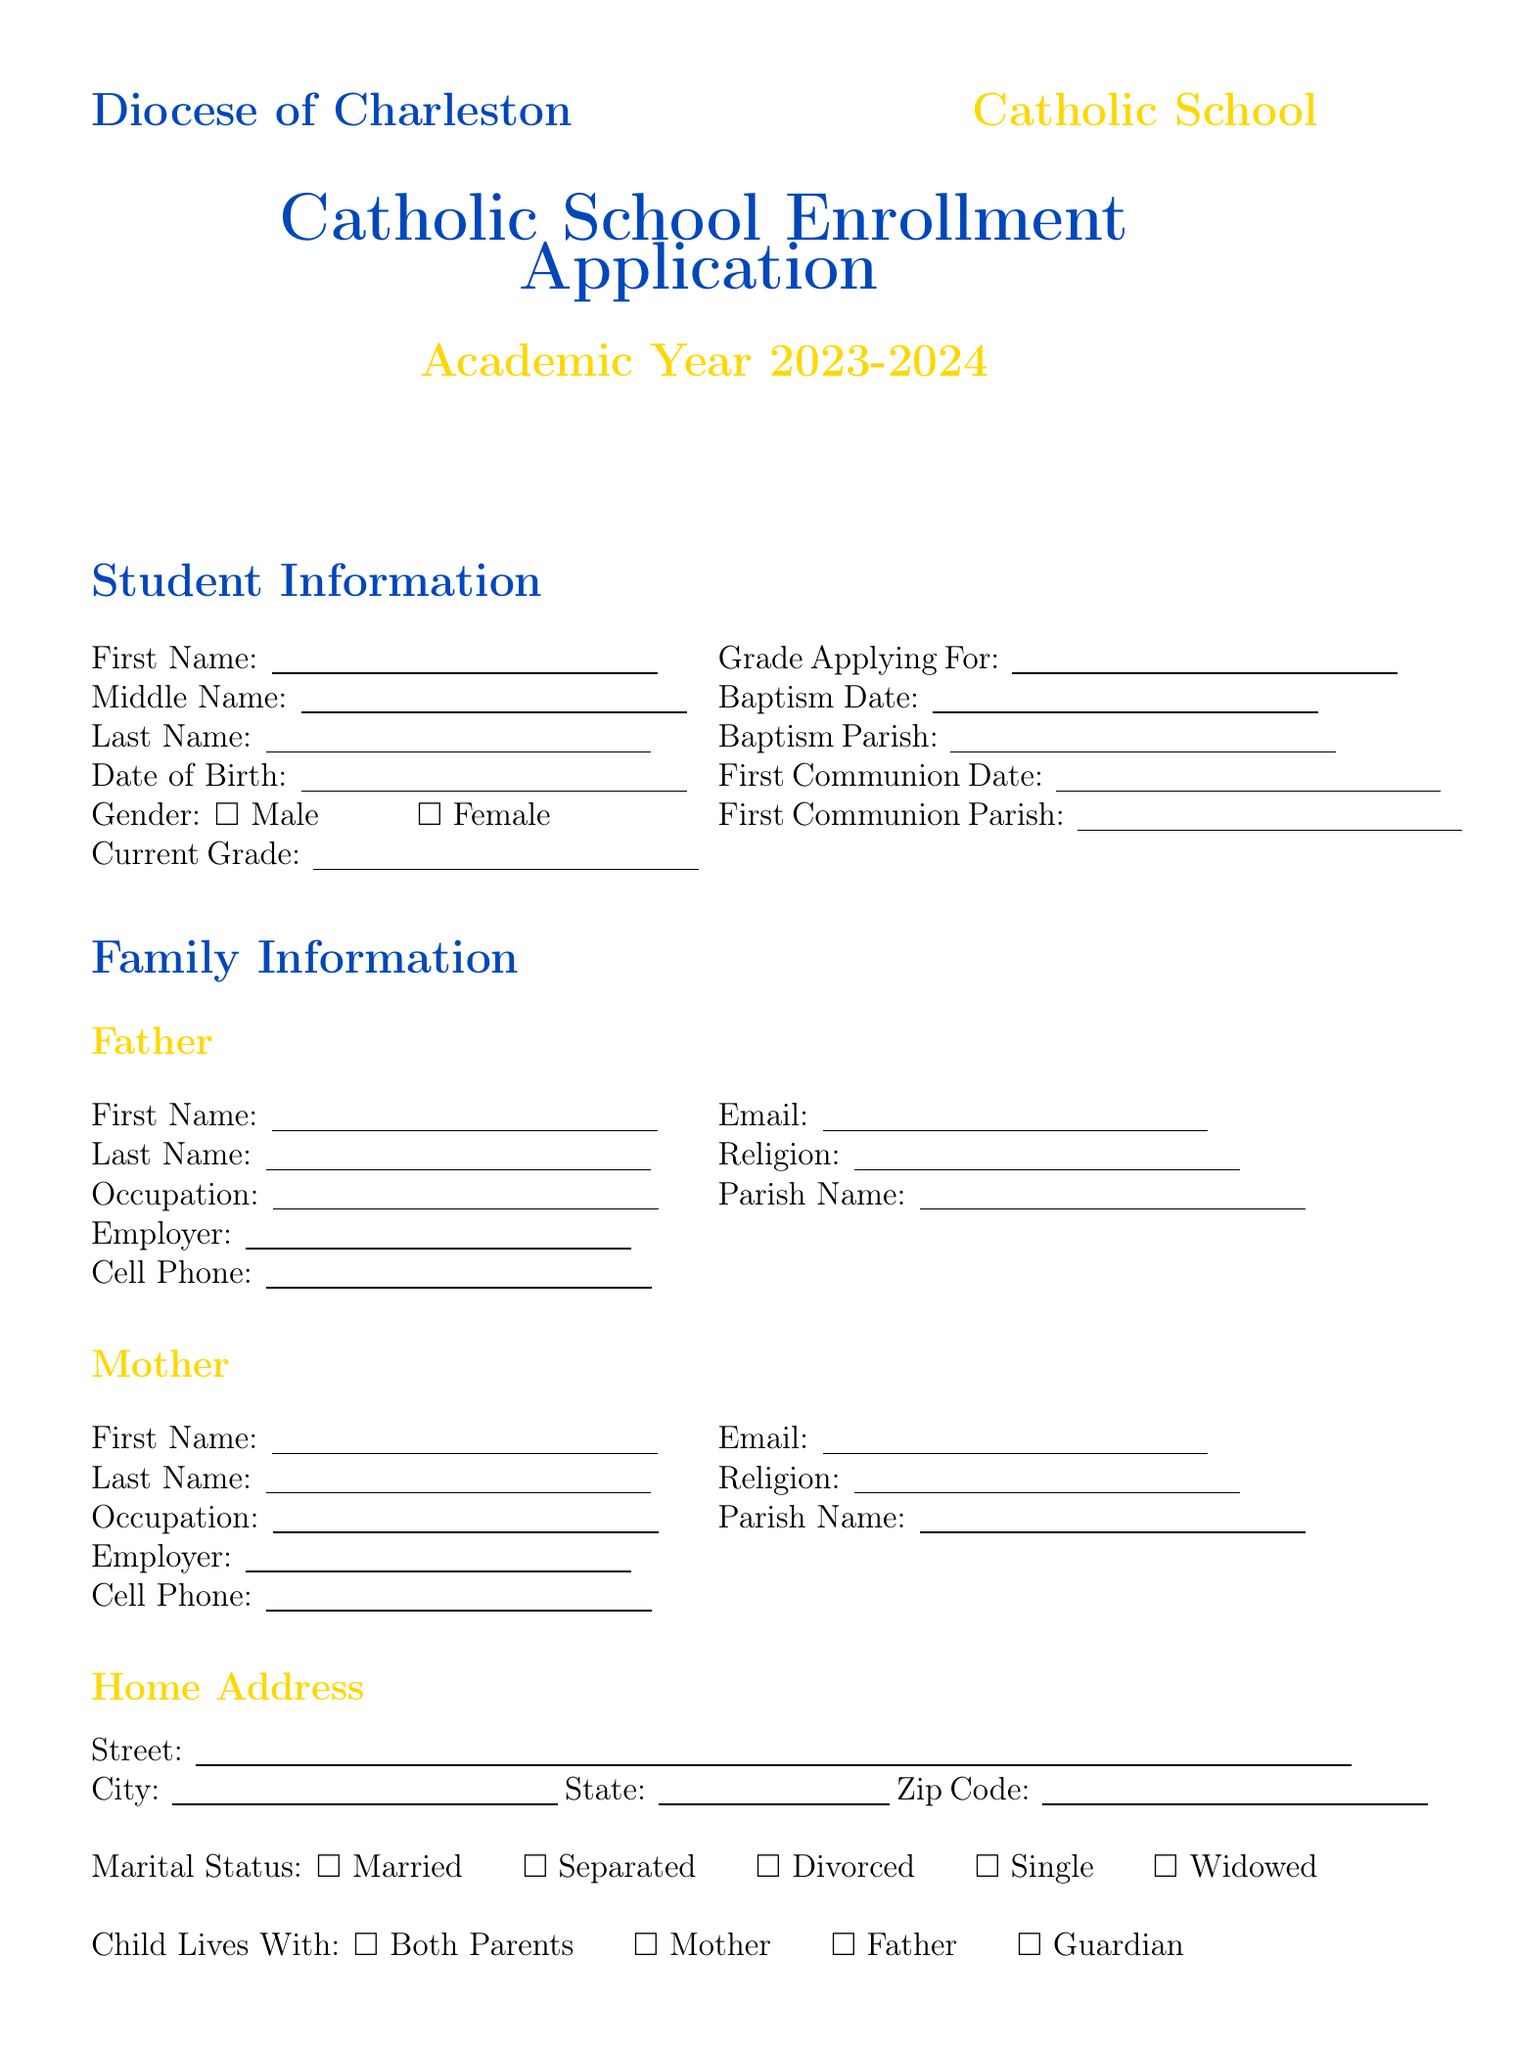What is the academic year for the application? The academic year listed in the document is specified at the beginning of the application.
Answer: 2023-2024 What is the student's last name? The student's last name is provided in the Student Information section of the document.
Answer: String What is the marital status options listed? The marital status section lists the various choices available for selection.
Answer: Married, Separated, Divorced, Single, Widowed What date is the baptism date? The baptism date is included in the Student Information section as part of the student's religious details.
Answer: Date Who is the father’s employer? The father's employer is mentioned in the Family Information section.
Answer: String If applying for financial aid, which scholarship programs can be chosen? The document lists specific scholarship programs available for financial aid applications.
Answer: Diocese of Charleston Scholarship, St. Elizabeth Ann Seton Scholarship, Other What is the relationship of the contact listed in the emergency contacts section? The emergency contacts section requires specifying the relationship of the contact person to the student.
Answer: String How many ministries can parents indicate participation in? The ministries section allows parents to choose from multiple options listed there.
Answer: Six What is required for the parent/guardian signature section? The document specifies that the parent or guardian must provide a name and date in this section.
Answer: Name and Date 